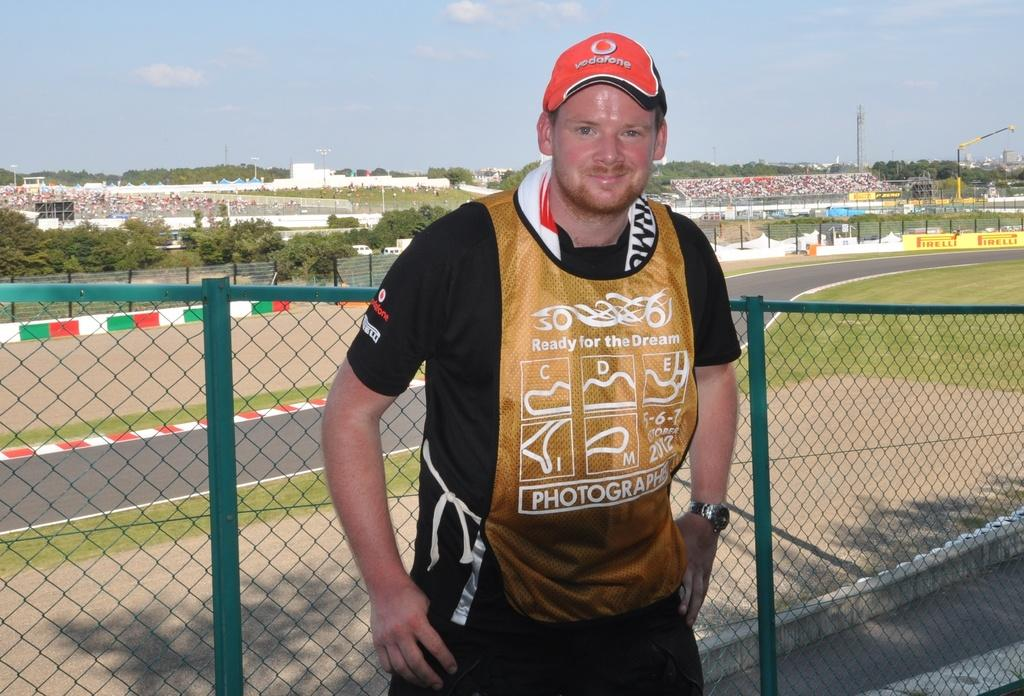What is the man in the image doing? The man is standing at the fence. What can be seen in the background of the image? There is a road, grass, poles, buildings, hoardings, an audience sitting on chairs, trees, cranes, and clouds in the sky. What type of punishment is being administered to the man in the image? There is no punishment being administered to the man in the image; he is simply standing at the fence. What can of toothpaste is being used by the audience sitting on chairs in the image? There is no toothpaste present in the image; the audience is sitting on chairs in the background. 